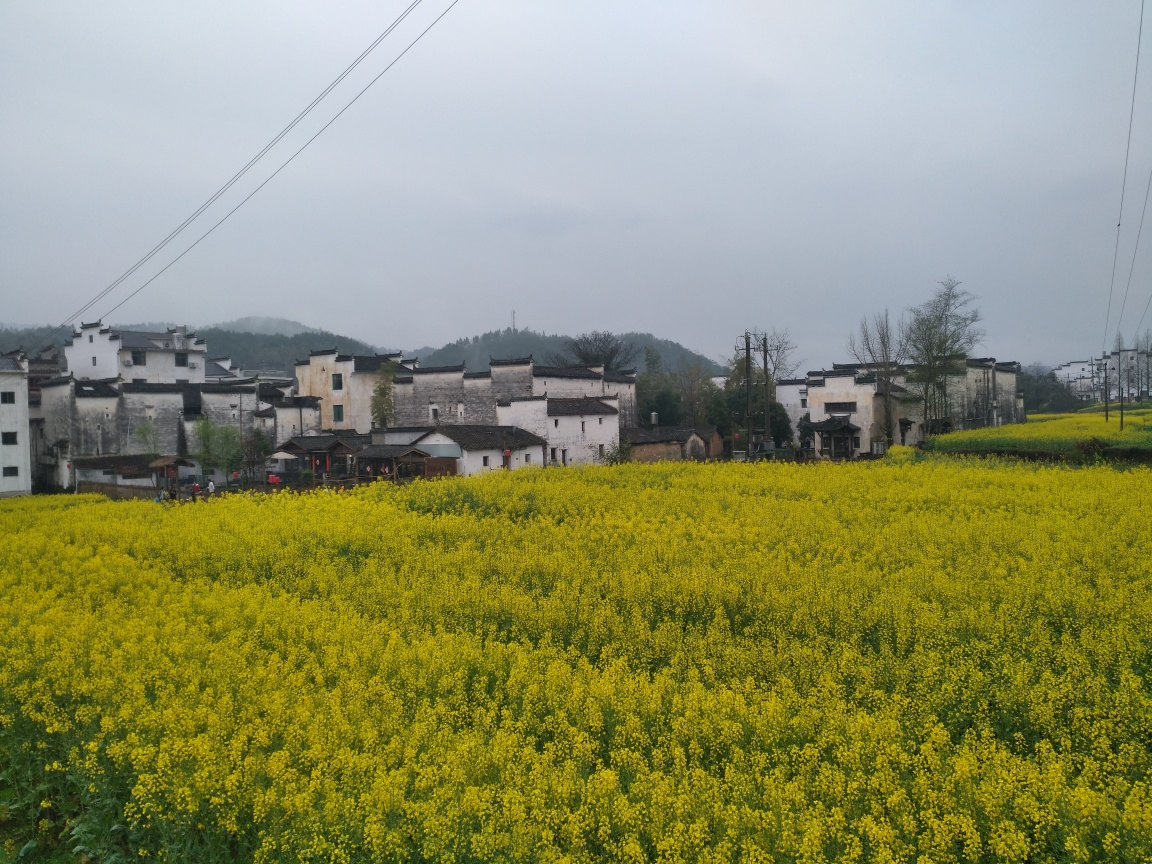Is the composition of the image well-balanced? The image presents a pleasing balance overall. The vibrant yellow flowers in the foreground offer a strong visual interest that contrasts with the muted buildings in the background. This contrast is well-positioned around the center of the frame, creating a visual anchor that divides the image harmoniously. Additionally, the overcast sky provides a neutral backdrop that allows the colors of the landscape and village to stand out. The composition adheres to the rule of thirds, with the horizon line set near the bottom third of the image, which often contributes to a well-balanced photograph. 